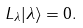Convert formula to latex. <formula><loc_0><loc_0><loc_500><loc_500>L _ { \lambda } | \lambda \rangle = 0 .</formula> 